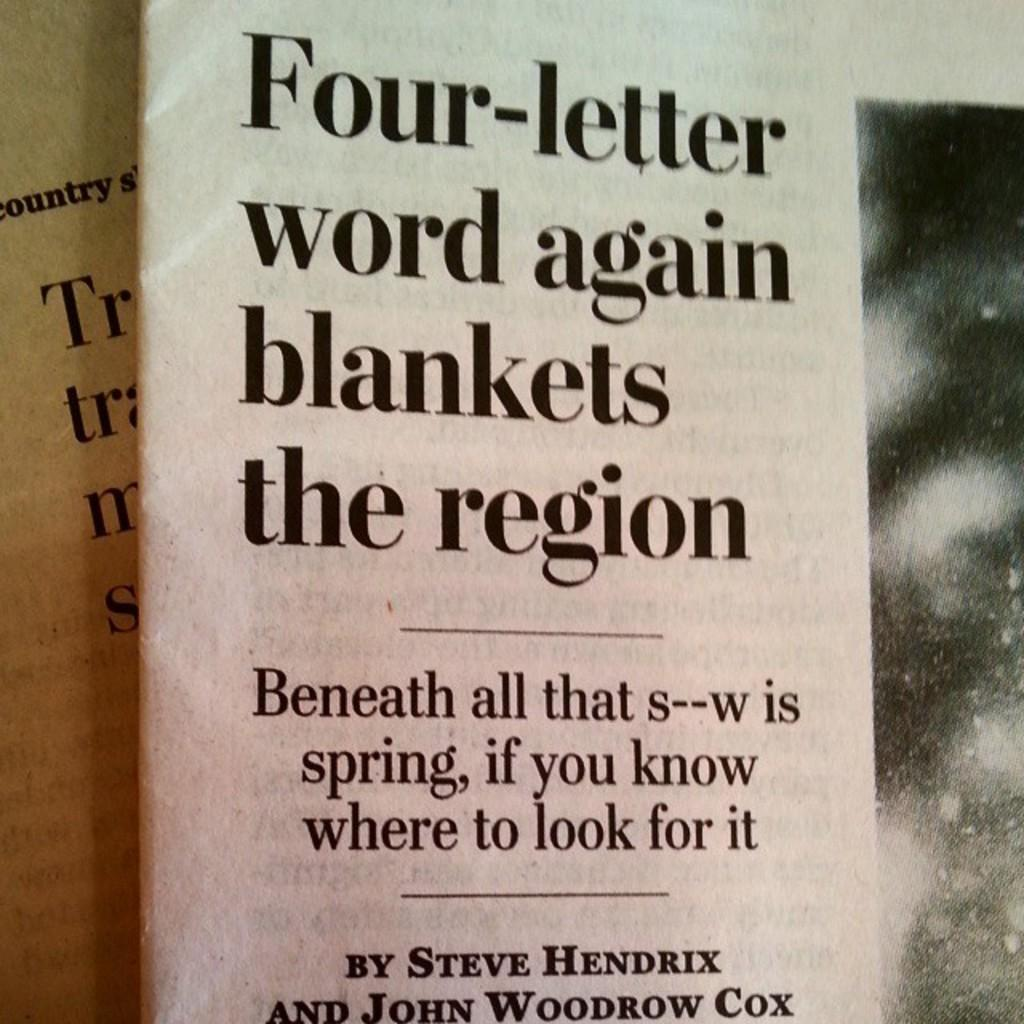Provide a one-sentence caption for the provided image. An article with the heading, Four-Letter word again blankets the region. 